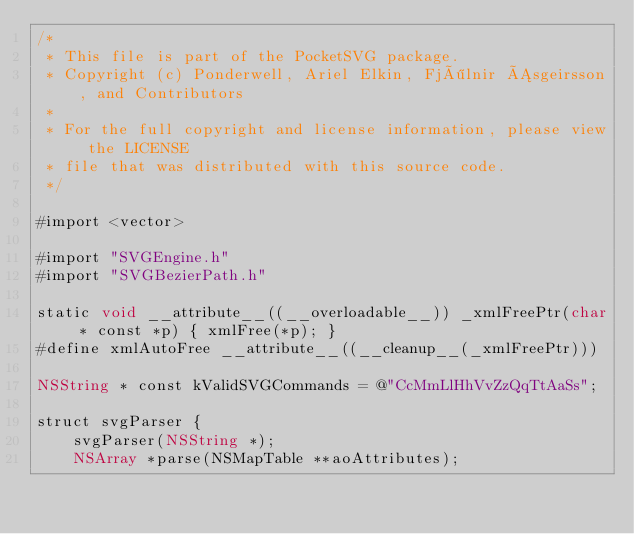<code> <loc_0><loc_0><loc_500><loc_500><_ObjectiveC_>/*
 * This file is part of the PocketSVG package.
 * Copyright (c) Ponderwell, Ariel Elkin, Fjölnir Ásgeirsson, and Contributors
 *
 * For the full copyright and license information, please view the LICENSE
 * file that was distributed with this source code.
 */

#import <vector>

#import "SVGEngine.h"
#import "SVGBezierPath.h"

static void __attribute__((__overloadable__)) _xmlFreePtr(char * const *p) { xmlFree(*p); }
#define xmlAutoFree __attribute__((__cleanup__(_xmlFreePtr)))

NSString * const kValidSVGCommands = @"CcMmLlHhVvZzQqTtAaSs";

struct svgParser {
    svgParser(NSString *);
    NSArray *parse(NSMapTable **aoAttributes);
</code> 